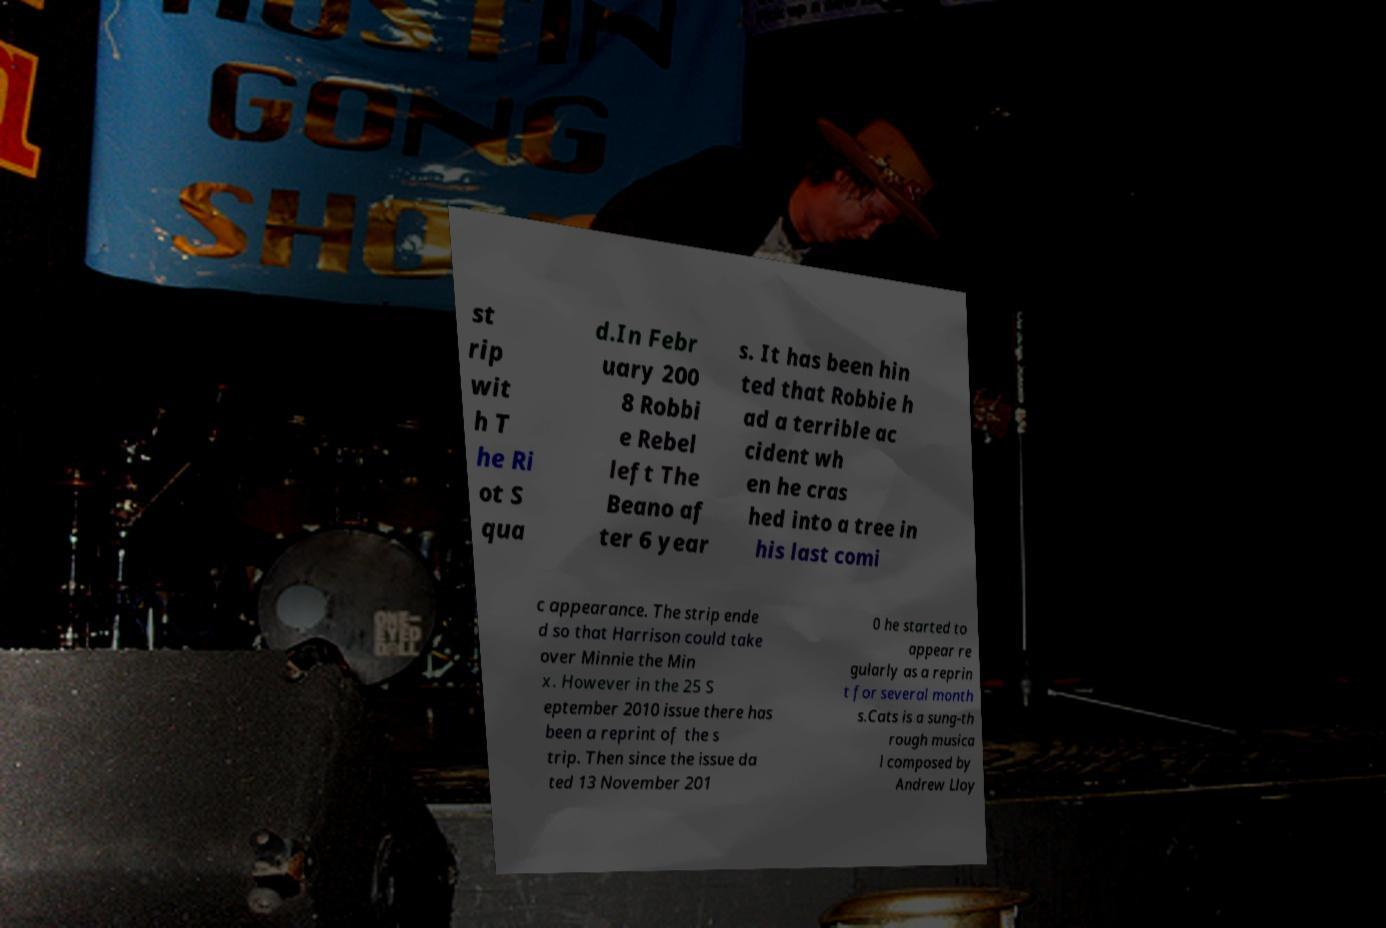Please identify and transcribe the text found in this image. st rip wit h T he Ri ot S qua d.In Febr uary 200 8 Robbi e Rebel left The Beano af ter 6 year s. It has been hin ted that Robbie h ad a terrible ac cident wh en he cras hed into a tree in his last comi c appearance. The strip ende d so that Harrison could take over Minnie the Min x. However in the 25 S eptember 2010 issue there has been a reprint of the s trip. Then since the issue da ted 13 November 201 0 he started to appear re gularly as a reprin t for several month s.Cats is a sung-th rough musica l composed by Andrew Lloy 